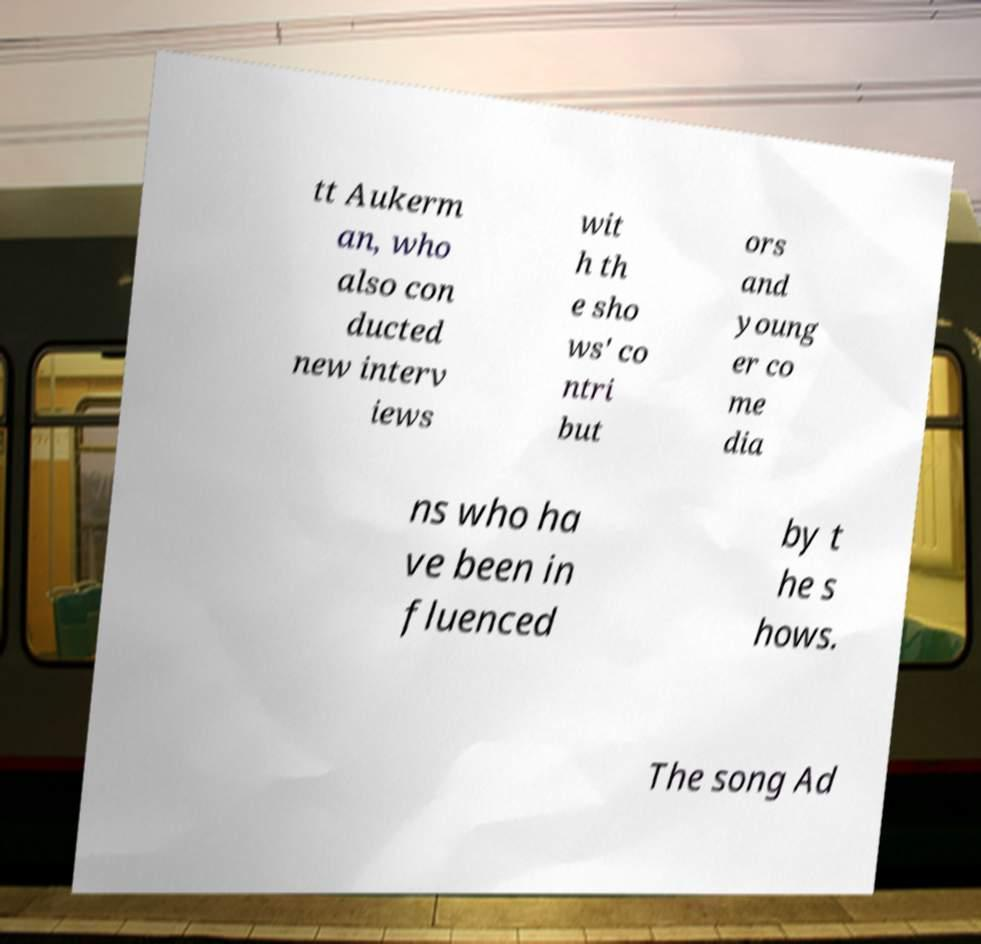Please read and relay the text visible in this image. What does it say? tt Aukerm an, who also con ducted new interv iews wit h th e sho ws' co ntri but ors and young er co me dia ns who ha ve been in fluenced by t he s hows. The song Ad 